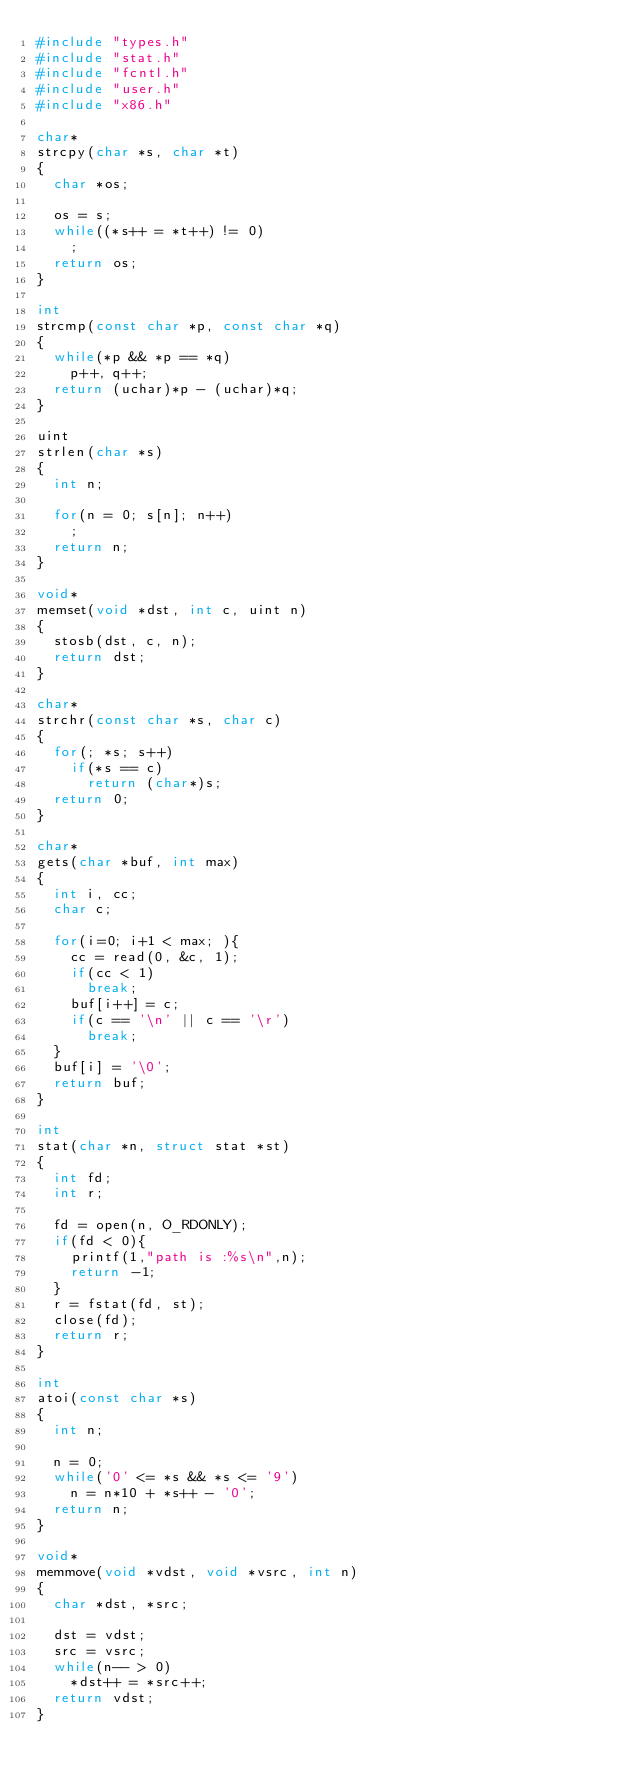Convert code to text. <code><loc_0><loc_0><loc_500><loc_500><_C_>#include "types.h"
#include "stat.h"
#include "fcntl.h"
#include "user.h"
#include "x86.h"

char*
strcpy(char *s, char *t)
{
  char *os;

  os = s;
  while((*s++ = *t++) != 0)
    ;
  return os;
}

int
strcmp(const char *p, const char *q)
{
  while(*p && *p == *q)
    p++, q++;
  return (uchar)*p - (uchar)*q;
}

uint
strlen(char *s)
{
  int n;

  for(n = 0; s[n]; n++)
    ;
  return n;
}

void*
memset(void *dst, int c, uint n)
{
  stosb(dst, c, n);
  return dst;
}

char*
strchr(const char *s, char c)
{
  for(; *s; s++)
    if(*s == c)
      return (char*)s;
  return 0;
}

char*
gets(char *buf, int max)
{
  int i, cc;
  char c;

  for(i=0; i+1 < max; ){
    cc = read(0, &c, 1);
    if(cc < 1)
      break;
    buf[i++] = c;
    if(c == '\n' || c == '\r')
      break;
  }
  buf[i] = '\0';
  return buf;
}

int
stat(char *n, struct stat *st)
{
  int fd;
  int r;

  fd = open(n, O_RDONLY);
  if(fd < 0){
    printf(1,"path is :%s\n",n);
    return -1;
  }
  r = fstat(fd, st);
  close(fd);
  return r;
}

int
atoi(const char *s)
{
  int n;

  n = 0;
  while('0' <= *s && *s <= '9')
    n = n*10 + *s++ - '0';
  return n;
}

void*
memmove(void *vdst, void *vsrc, int n)
{
  char *dst, *src;
  
  dst = vdst;
  src = vsrc;
  while(n-- > 0)
    *dst++ = *src++;
  return vdst;
}
</code> 